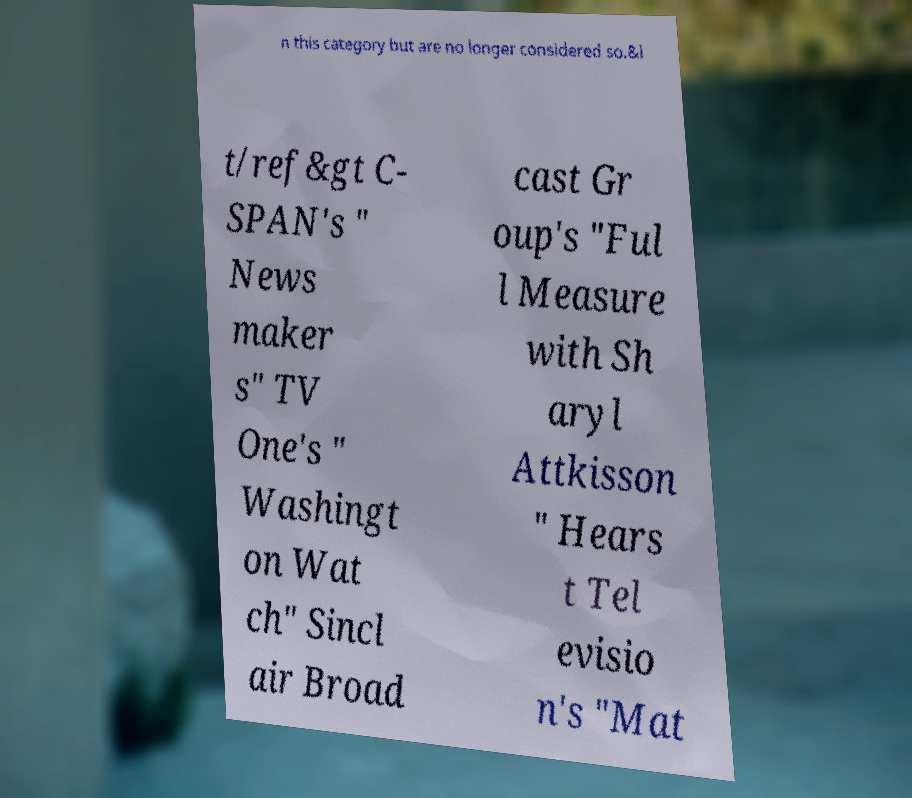Please identify and transcribe the text found in this image. n this category but are no longer considered so.&l t/ref&gt C- SPAN's " News maker s" TV One's " Washingt on Wat ch" Sincl air Broad cast Gr oup's "Ful l Measure with Sh aryl Attkisson " Hears t Tel evisio n's "Mat 